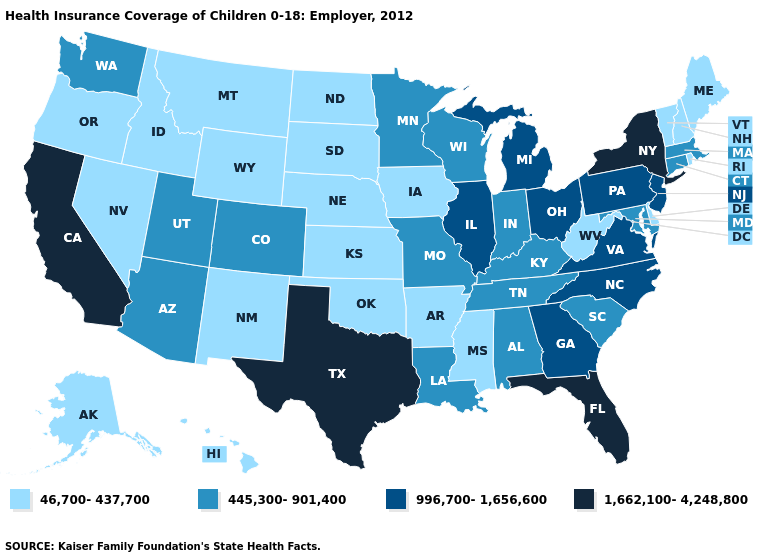How many symbols are there in the legend?
Give a very brief answer. 4. Among the states that border Georgia , which have the lowest value?
Give a very brief answer. Alabama, South Carolina, Tennessee. Which states have the highest value in the USA?
Quick response, please. California, Florida, New York, Texas. What is the lowest value in states that border Idaho?
Be succinct. 46,700-437,700. What is the value of Utah?
Short answer required. 445,300-901,400. What is the value of Arizona?
Quick response, please. 445,300-901,400. Name the states that have a value in the range 445,300-901,400?
Answer briefly. Alabama, Arizona, Colorado, Connecticut, Indiana, Kentucky, Louisiana, Maryland, Massachusetts, Minnesota, Missouri, South Carolina, Tennessee, Utah, Washington, Wisconsin. Is the legend a continuous bar?
Answer briefly. No. Name the states that have a value in the range 1,662,100-4,248,800?
Keep it brief. California, Florida, New York, Texas. What is the value of New Jersey?
Concise answer only. 996,700-1,656,600. Name the states that have a value in the range 46,700-437,700?
Short answer required. Alaska, Arkansas, Delaware, Hawaii, Idaho, Iowa, Kansas, Maine, Mississippi, Montana, Nebraska, Nevada, New Hampshire, New Mexico, North Dakota, Oklahoma, Oregon, Rhode Island, South Dakota, Vermont, West Virginia, Wyoming. How many symbols are there in the legend?
Concise answer only. 4. Name the states that have a value in the range 445,300-901,400?
Write a very short answer. Alabama, Arizona, Colorado, Connecticut, Indiana, Kentucky, Louisiana, Maryland, Massachusetts, Minnesota, Missouri, South Carolina, Tennessee, Utah, Washington, Wisconsin. Which states hav the highest value in the MidWest?
Concise answer only. Illinois, Michigan, Ohio. Which states have the highest value in the USA?
Write a very short answer. California, Florida, New York, Texas. 